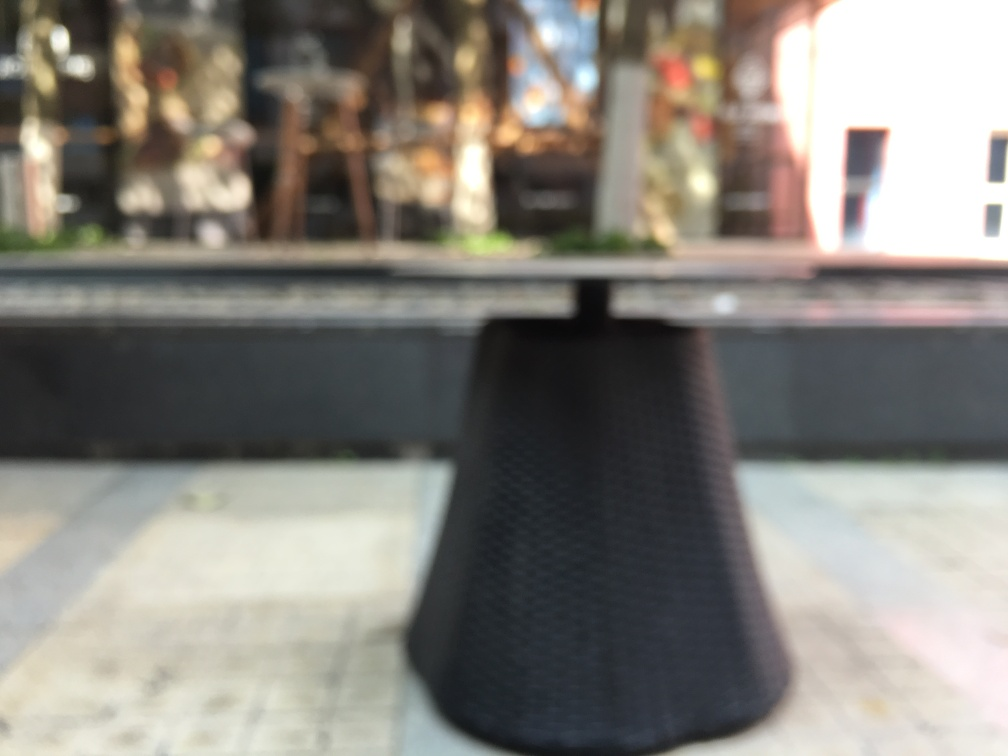Is there anything in the image that can help determine the time of day or season? Although it's difficult to determine precise details due to the blurriness, the lighting suggests that it could be taken during daylight, possibly midday given the bright glimpses and reflections. There aren't definitive indications of the season, but the presence of greenery might imply it's taken during a time when plants are flourishing, such as spring or summer. 